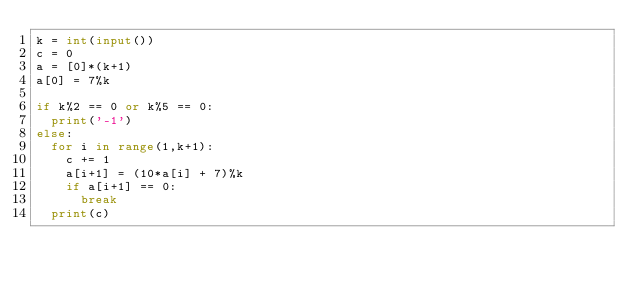<code> <loc_0><loc_0><loc_500><loc_500><_Python_>k = int(input())
c = 0
a = [0]*(k+1)
a[0] = 7%k

if k%2 == 0 or k%5 == 0:
	print('-1')
else:
	for i in range(1,k+1):
		c += 1 
		a[i+1] = (10*a[i] + 7)%k
		if a[i+1] == 0:
			break
	print(c)</code> 